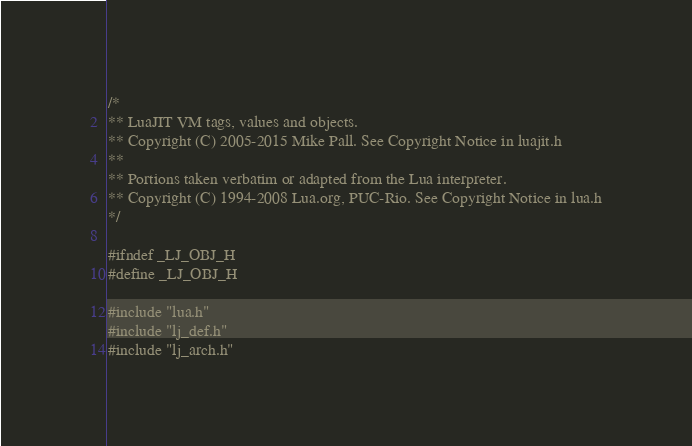<code> <loc_0><loc_0><loc_500><loc_500><_C_>/*
** LuaJIT VM tags, values and objects.
** Copyright (C) 2005-2015 Mike Pall. See Copyright Notice in luajit.h
**
** Portions taken verbatim or adapted from the Lua interpreter.
** Copyright (C) 1994-2008 Lua.org, PUC-Rio. See Copyright Notice in lua.h
*/

#ifndef _LJ_OBJ_H
#define _LJ_OBJ_H

#include "lua.h"
#include "lj_def.h"
#include "lj_arch.h"
</code> 